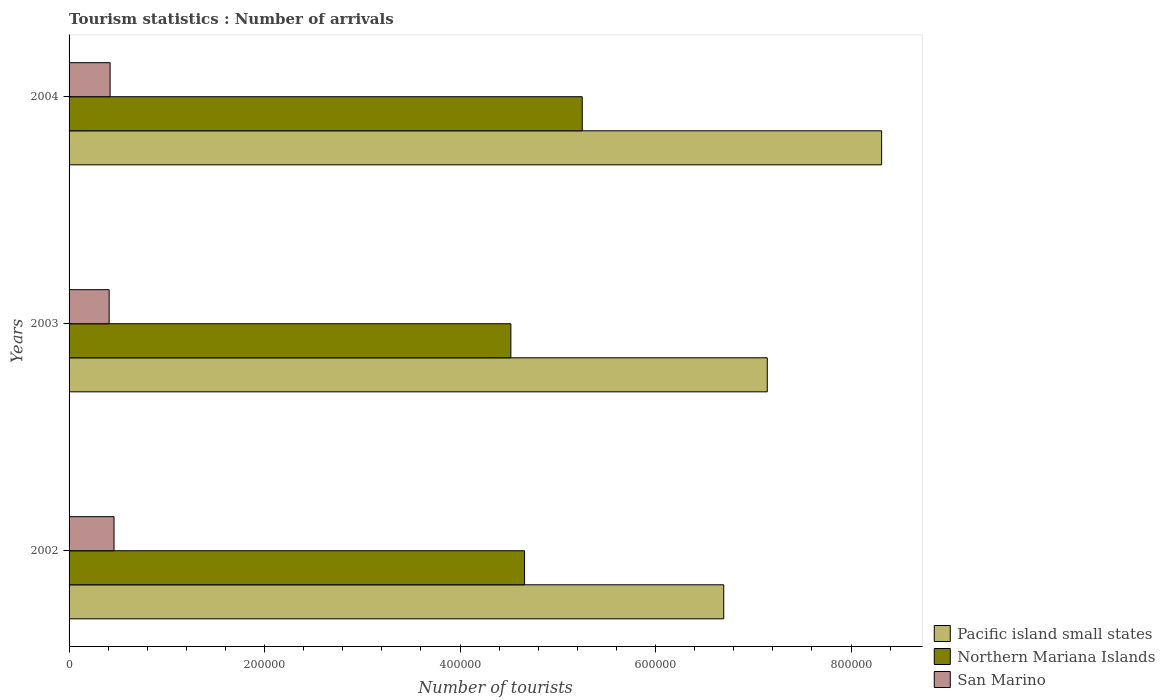Are the number of bars per tick equal to the number of legend labels?
Offer a terse response. Yes. Are the number of bars on each tick of the Y-axis equal?
Make the answer very short. Yes. How many bars are there on the 2nd tick from the bottom?
Make the answer very short. 3. What is the number of tourist arrivals in Pacific island small states in 2003?
Your answer should be very brief. 7.14e+05. Across all years, what is the maximum number of tourist arrivals in Pacific island small states?
Provide a short and direct response. 8.31e+05. Across all years, what is the minimum number of tourist arrivals in San Marino?
Keep it short and to the point. 4.10e+04. In which year was the number of tourist arrivals in Northern Mariana Islands minimum?
Ensure brevity in your answer.  2003. What is the total number of tourist arrivals in Northern Mariana Islands in the graph?
Provide a succinct answer. 1.44e+06. What is the difference between the number of tourist arrivals in San Marino in 2002 and that in 2003?
Your answer should be compact. 5000. What is the difference between the number of tourist arrivals in Northern Mariana Islands in 2004 and the number of tourist arrivals in San Marino in 2003?
Offer a very short reply. 4.84e+05. What is the average number of tourist arrivals in San Marino per year?
Give a very brief answer. 4.30e+04. In the year 2004, what is the difference between the number of tourist arrivals in Pacific island small states and number of tourist arrivals in Northern Mariana Islands?
Offer a terse response. 3.06e+05. What is the ratio of the number of tourist arrivals in Northern Mariana Islands in 2002 to that in 2003?
Give a very brief answer. 1.03. What is the difference between the highest and the second highest number of tourist arrivals in Northern Mariana Islands?
Offer a terse response. 5.90e+04. What is the difference between the highest and the lowest number of tourist arrivals in Northern Mariana Islands?
Keep it short and to the point. 7.30e+04. Is the sum of the number of tourist arrivals in Pacific island small states in 2002 and 2004 greater than the maximum number of tourist arrivals in Northern Mariana Islands across all years?
Your answer should be compact. Yes. What does the 3rd bar from the top in 2002 represents?
Provide a short and direct response. Pacific island small states. What does the 2nd bar from the bottom in 2002 represents?
Offer a terse response. Northern Mariana Islands. What is the difference between two consecutive major ticks on the X-axis?
Your answer should be very brief. 2.00e+05. Where does the legend appear in the graph?
Offer a terse response. Bottom right. How many legend labels are there?
Your answer should be very brief. 3. How are the legend labels stacked?
Give a very brief answer. Vertical. What is the title of the graph?
Your answer should be very brief. Tourism statistics : Number of arrivals. What is the label or title of the X-axis?
Offer a very short reply. Number of tourists. What is the Number of tourists of Pacific island small states in 2002?
Provide a short and direct response. 6.70e+05. What is the Number of tourists in Northern Mariana Islands in 2002?
Your response must be concise. 4.66e+05. What is the Number of tourists in San Marino in 2002?
Your answer should be very brief. 4.60e+04. What is the Number of tourists in Pacific island small states in 2003?
Your answer should be very brief. 7.14e+05. What is the Number of tourists of Northern Mariana Islands in 2003?
Your answer should be very brief. 4.52e+05. What is the Number of tourists of San Marino in 2003?
Your answer should be very brief. 4.10e+04. What is the Number of tourists in Pacific island small states in 2004?
Keep it short and to the point. 8.31e+05. What is the Number of tourists in Northern Mariana Islands in 2004?
Provide a short and direct response. 5.25e+05. What is the Number of tourists in San Marino in 2004?
Ensure brevity in your answer.  4.20e+04. Across all years, what is the maximum Number of tourists in Pacific island small states?
Your answer should be very brief. 8.31e+05. Across all years, what is the maximum Number of tourists of Northern Mariana Islands?
Ensure brevity in your answer.  5.25e+05. Across all years, what is the maximum Number of tourists in San Marino?
Your answer should be very brief. 4.60e+04. Across all years, what is the minimum Number of tourists of Pacific island small states?
Provide a succinct answer. 6.70e+05. Across all years, what is the minimum Number of tourists of Northern Mariana Islands?
Your response must be concise. 4.52e+05. Across all years, what is the minimum Number of tourists in San Marino?
Offer a very short reply. 4.10e+04. What is the total Number of tourists in Pacific island small states in the graph?
Provide a short and direct response. 2.22e+06. What is the total Number of tourists of Northern Mariana Islands in the graph?
Offer a terse response. 1.44e+06. What is the total Number of tourists of San Marino in the graph?
Give a very brief answer. 1.29e+05. What is the difference between the Number of tourists in Pacific island small states in 2002 and that in 2003?
Provide a short and direct response. -4.45e+04. What is the difference between the Number of tourists in Northern Mariana Islands in 2002 and that in 2003?
Your response must be concise. 1.40e+04. What is the difference between the Number of tourists of San Marino in 2002 and that in 2003?
Offer a terse response. 5000. What is the difference between the Number of tourists of Pacific island small states in 2002 and that in 2004?
Provide a short and direct response. -1.62e+05. What is the difference between the Number of tourists of Northern Mariana Islands in 2002 and that in 2004?
Offer a terse response. -5.90e+04. What is the difference between the Number of tourists of San Marino in 2002 and that in 2004?
Keep it short and to the point. 4000. What is the difference between the Number of tourists of Pacific island small states in 2003 and that in 2004?
Ensure brevity in your answer.  -1.17e+05. What is the difference between the Number of tourists in Northern Mariana Islands in 2003 and that in 2004?
Provide a short and direct response. -7.30e+04. What is the difference between the Number of tourists in San Marino in 2003 and that in 2004?
Give a very brief answer. -1000. What is the difference between the Number of tourists of Pacific island small states in 2002 and the Number of tourists of Northern Mariana Islands in 2003?
Ensure brevity in your answer.  2.18e+05. What is the difference between the Number of tourists in Pacific island small states in 2002 and the Number of tourists in San Marino in 2003?
Keep it short and to the point. 6.29e+05. What is the difference between the Number of tourists of Northern Mariana Islands in 2002 and the Number of tourists of San Marino in 2003?
Ensure brevity in your answer.  4.25e+05. What is the difference between the Number of tourists of Pacific island small states in 2002 and the Number of tourists of Northern Mariana Islands in 2004?
Keep it short and to the point. 1.45e+05. What is the difference between the Number of tourists of Pacific island small states in 2002 and the Number of tourists of San Marino in 2004?
Keep it short and to the point. 6.28e+05. What is the difference between the Number of tourists in Northern Mariana Islands in 2002 and the Number of tourists in San Marino in 2004?
Offer a terse response. 4.24e+05. What is the difference between the Number of tourists in Pacific island small states in 2003 and the Number of tourists in Northern Mariana Islands in 2004?
Your response must be concise. 1.89e+05. What is the difference between the Number of tourists in Pacific island small states in 2003 and the Number of tourists in San Marino in 2004?
Keep it short and to the point. 6.72e+05. What is the difference between the Number of tourists in Northern Mariana Islands in 2003 and the Number of tourists in San Marino in 2004?
Provide a short and direct response. 4.10e+05. What is the average Number of tourists in Pacific island small states per year?
Your response must be concise. 7.38e+05. What is the average Number of tourists of Northern Mariana Islands per year?
Offer a very short reply. 4.81e+05. What is the average Number of tourists in San Marino per year?
Offer a terse response. 4.30e+04. In the year 2002, what is the difference between the Number of tourists in Pacific island small states and Number of tourists in Northern Mariana Islands?
Offer a very short reply. 2.04e+05. In the year 2002, what is the difference between the Number of tourists in Pacific island small states and Number of tourists in San Marino?
Ensure brevity in your answer.  6.24e+05. In the year 2002, what is the difference between the Number of tourists in Northern Mariana Islands and Number of tourists in San Marino?
Ensure brevity in your answer.  4.20e+05. In the year 2003, what is the difference between the Number of tourists of Pacific island small states and Number of tourists of Northern Mariana Islands?
Ensure brevity in your answer.  2.62e+05. In the year 2003, what is the difference between the Number of tourists in Pacific island small states and Number of tourists in San Marino?
Your answer should be very brief. 6.73e+05. In the year 2003, what is the difference between the Number of tourists of Northern Mariana Islands and Number of tourists of San Marino?
Keep it short and to the point. 4.11e+05. In the year 2004, what is the difference between the Number of tourists in Pacific island small states and Number of tourists in Northern Mariana Islands?
Your answer should be very brief. 3.06e+05. In the year 2004, what is the difference between the Number of tourists of Pacific island small states and Number of tourists of San Marino?
Provide a short and direct response. 7.89e+05. In the year 2004, what is the difference between the Number of tourists of Northern Mariana Islands and Number of tourists of San Marino?
Provide a short and direct response. 4.83e+05. What is the ratio of the Number of tourists in Pacific island small states in 2002 to that in 2003?
Make the answer very short. 0.94. What is the ratio of the Number of tourists in Northern Mariana Islands in 2002 to that in 2003?
Your response must be concise. 1.03. What is the ratio of the Number of tourists in San Marino in 2002 to that in 2003?
Ensure brevity in your answer.  1.12. What is the ratio of the Number of tourists of Pacific island small states in 2002 to that in 2004?
Your answer should be very brief. 0.81. What is the ratio of the Number of tourists in Northern Mariana Islands in 2002 to that in 2004?
Offer a terse response. 0.89. What is the ratio of the Number of tourists in San Marino in 2002 to that in 2004?
Give a very brief answer. 1.1. What is the ratio of the Number of tourists of Pacific island small states in 2003 to that in 2004?
Give a very brief answer. 0.86. What is the ratio of the Number of tourists in Northern Mariana Islands in 2003 to that in 2004?
Make the answer very short. 0.86. What is the ratio of the Number of tourists in San Marino in 2003 to that in 2004?
Provide a succinct answer. 0.98. What is the difference between the highest and the second highest Number of tourists of Pacific island small states?
Give a very brief answer. 1.17e+05. What is the difference between the highest and the second highest Number of tourists in Northern Mariana Islands?
Provide a succinct answer. 5.90e+04. What is the difference between the highest and the second highest Number of tourists in San Marino?
Your response must be concise. 4000. What is the difference between the highest and the lowest Number of tourists in Pacific island small states?
Offer a very short reply. 1.62e+05. What is the difference between the highest and the lowest Number of tourists of Northern Mariana Islands?
Provide a short and direct response. 7.30e+04. 